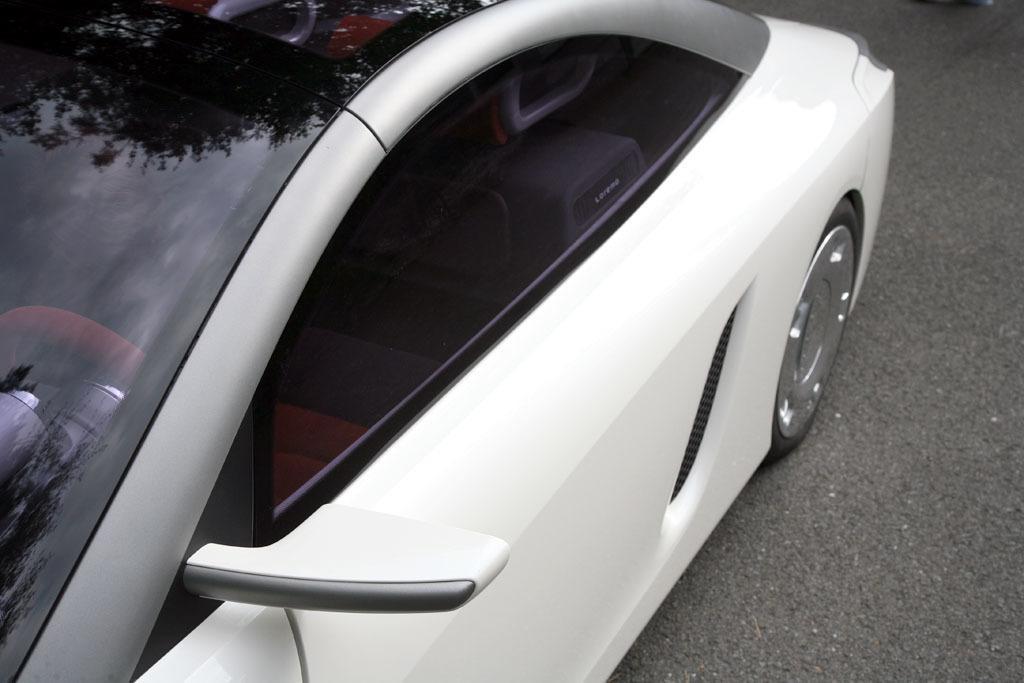Please provide a concise description of this image. In this image we can see a white color car which is on road. 